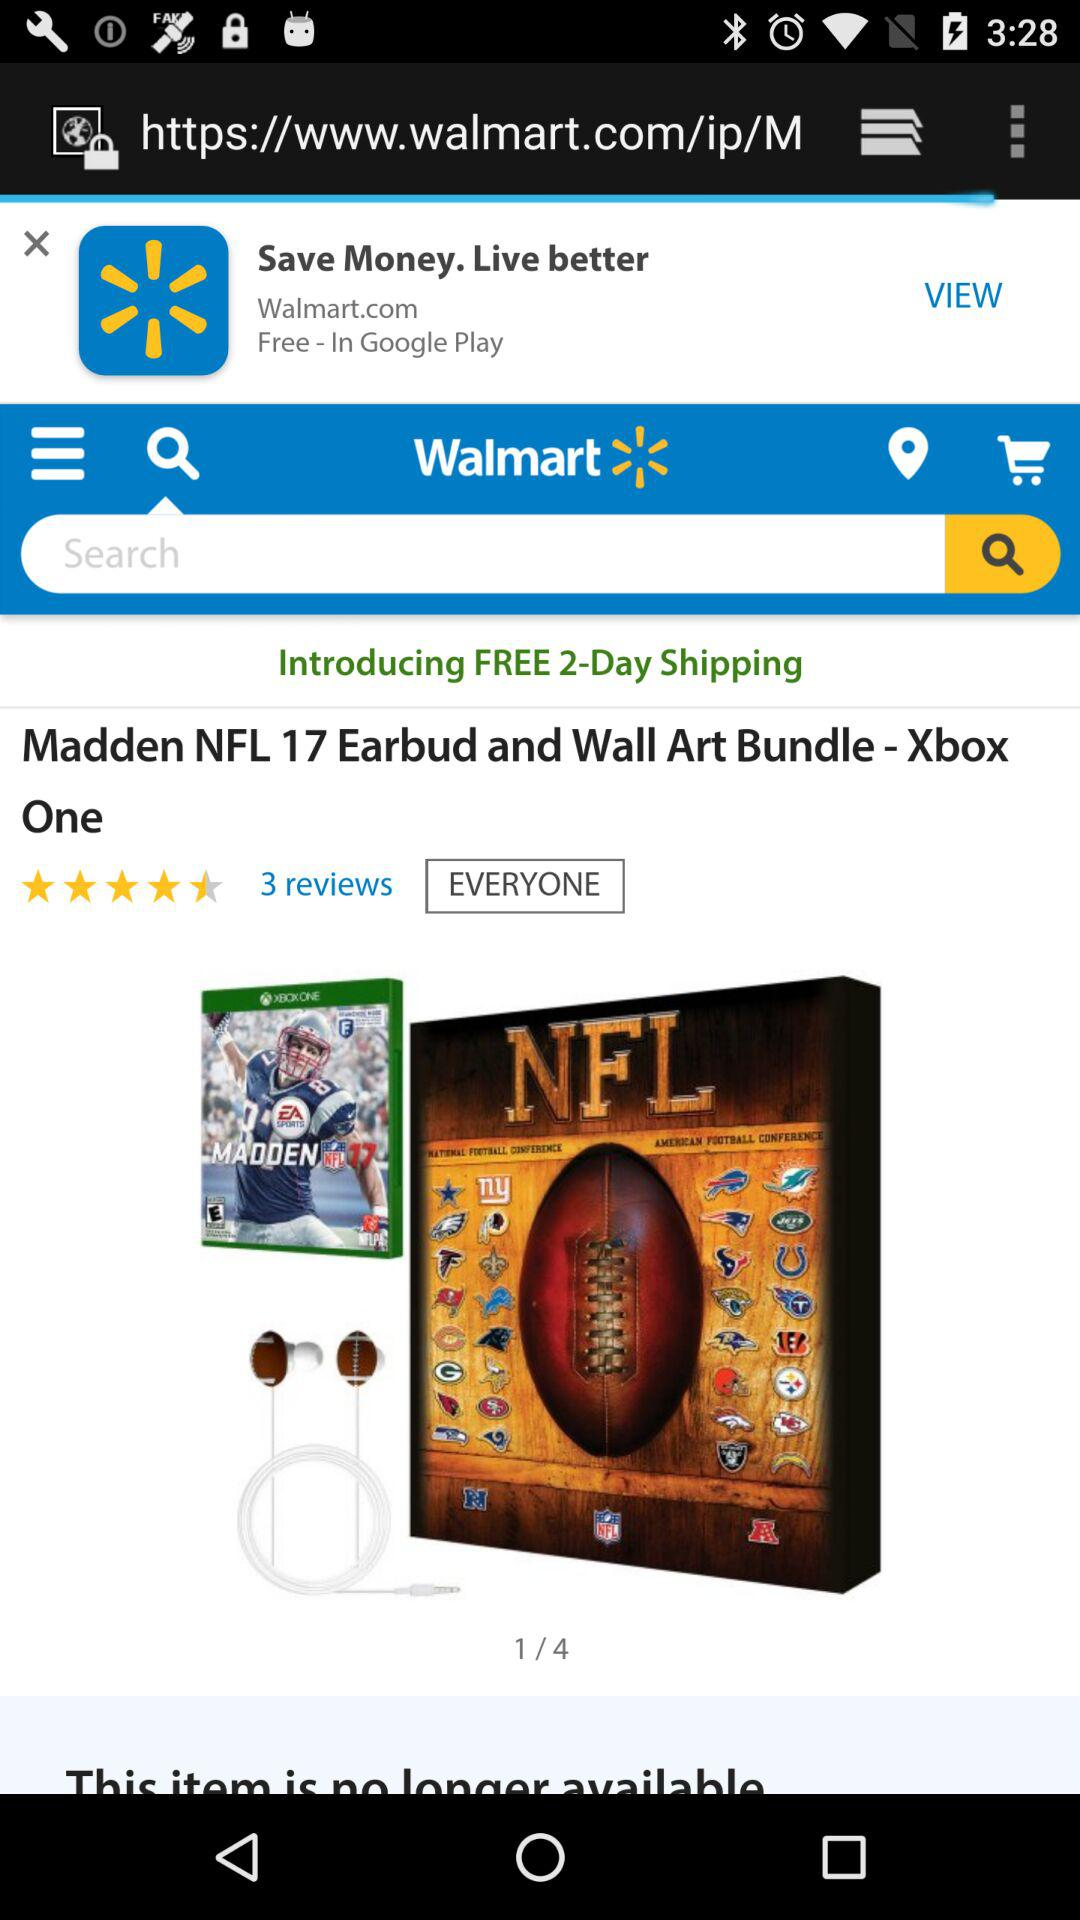How many reviews does the product have?
Answer the question using a single word or phrase. 3 